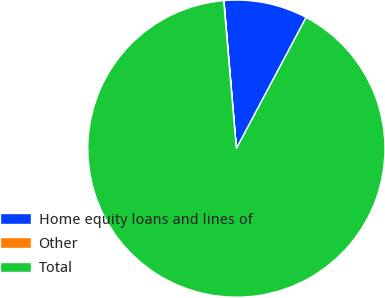Convert chart to OTSL. <chart><loc_0><loc_0><loc_500><loc_500><pie_chart><fcel>Home equity loans and lines of<fcel>Other<fcel>Total<nl><fcel>9.11%<fcel>0.03%<fcel>90.86%<nl></chart> 